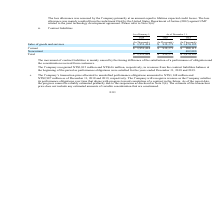According to United Micro Electronics's financial document, What causes the  movement of contract liabilities? mainly caused by the timing difference of the satisfaction of a performance of obligation and the consideration received from customers.. The document states: "The movement of contract liabilities is mainly caused by the timing difference of the satisfaction of a performance of obligation and the consideratio..." Also, What was the revenue recorded from the contract liabilities balance at the beginning of the period for the years ended December 31, 2018? According to the financial document, NT$3,815 million. The relevant text states: "The Company recognized NT$3,815 million and NT$616 million, respectively, in revenues from the contract liabilities balance at the beginnin..." Also, What was the revenue recorded from the contract liabilities balance at the beginning of the period for the years ended December 31, 2019? According to the financial document, NT$616 million. The relevant text states: "The Company recognized NT$3,815 million and NT$616 million, respectively, in revenues from the contract liabilities balance at the beginning of the period as..." Also, can you calculate: What are the average Sales of goods and services for December 31, 2018 to 2019? To answer this question, I need to perform calculations using the financial data. The calculation is: (932,371+1,470,195) / 2, which equals 1201283 (in thousands). This is based on the information: "les of goods and services $ 3,951,414 $ 932,371 $ 1,470,195 Current $ 3,951,414 $ 932,371 $ 988,115 Noncurrent — — 482,080 Total $ 3,951,414 $ 932,371 $ 1,470, usands) Sales of goods and services $ 3,..." The key data points involved are: 1,470,195, 932,371. Also, can you calculate: What is the increase/ (decrease) in Sales of goods and services for December 31, 2018 to 2019? Based on the calculation: 1,470,195-932,371, the result is 537824 (in thousands). This is based on the information: "les of goods and services $ 3,951,414 $ 932,371 $ 1,470,195 Current $ 3,951,414 $ 932,371 $ 988,115 Noncurrent — — 482,080 Total $ 3,951,414 $ 932,371 $ 1,470, usands) Sales of goods and services $ 3,..." The key data points involved are: 1,470,195, 932,371. Also, can you calculate: What is the increase/ (decrease) in Sales of goods and services for January 1, 2018 to December 31, 2018? Based on the calculation: 932,371-3,951,414, the result is -3019043 (in thousands). This is based on the information: "nds) (In Thousands) Sales of goods and services $ 3,951,414 $ 932,371 $ 1,470,195 Current $ 3,951,414 $ 932,371 $ 988,115 Noncurrent — — 482,080 Total $ 3,951, usands) Sales of goods and services $ 3,..." The key data points involved are: 3,951,414, 932,371. 